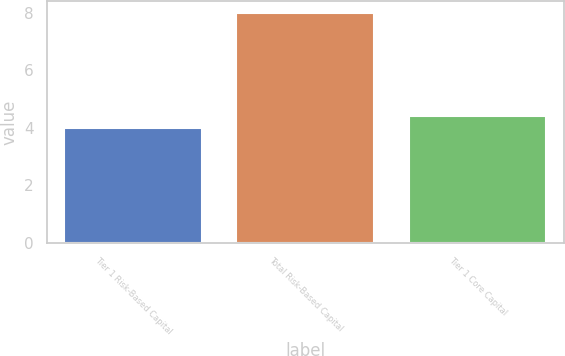Convert chart to OTSL. <chart><loc_0><loc_0><loc_500><loc_500><bar_chart><fcel>Tier 1 Risk-Based Capital<fcel>Total Risk-Based Capital<fcel>Tier 1 Core Capital<nl><fcel>4<fcel>8<fcel>4.4<nl></chart> 